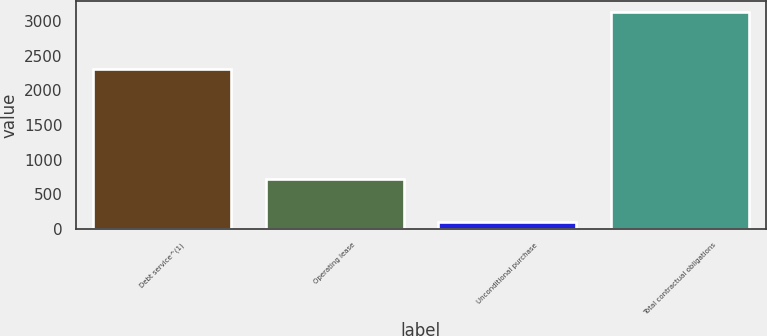Convert chart to OTSL. <chart><loc_0><loc_0><loc_500><loc_500><bar_chart><fcel>Debt service^(1)<fcel>Operating lease<fcel>Unconditional purchase<fcel>Total contractual obligations<nl><fcel>2312.2<fcel>721.8<fcel>95.1<fcel>3129.1<nl></chart> 